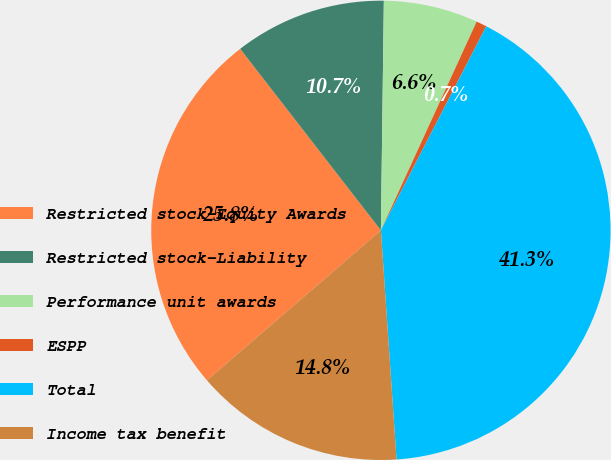<chart> <loc_0><loc_0><loc_500><loc_500><pie_chart><fcel>Restricted stock-Equity Awards<fcel>Restricted stock-Liability<fcel>Performance unit awards<fcel>ESPP<fcel>Total<fcel>Income tax benefit<nl><fcel>25.83%<fcel>10.7%<fcel>6.64%<fcel>0.74%<fcel>41.33%<fcel>14.76%<nl></chart> 